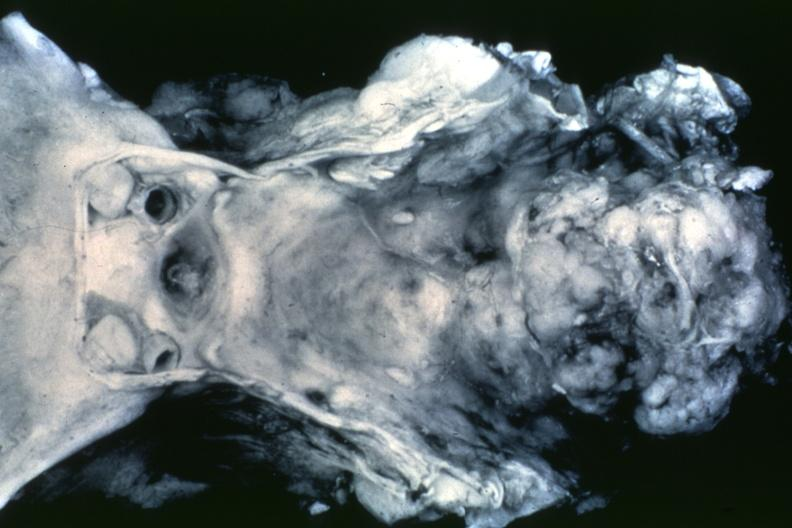what is present?
Answer the question using a single word or phrase. Bone, clivus 